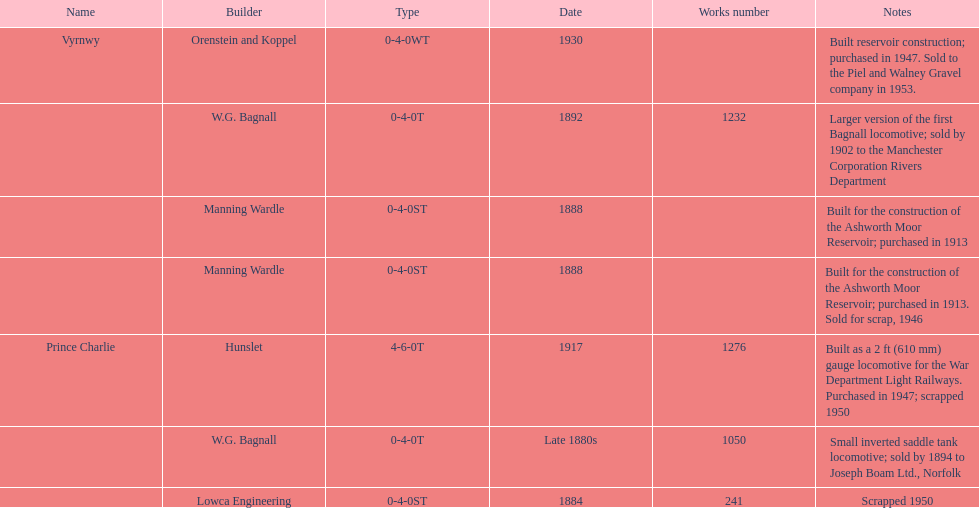How many locomotives were built before the 1900s? 5. 